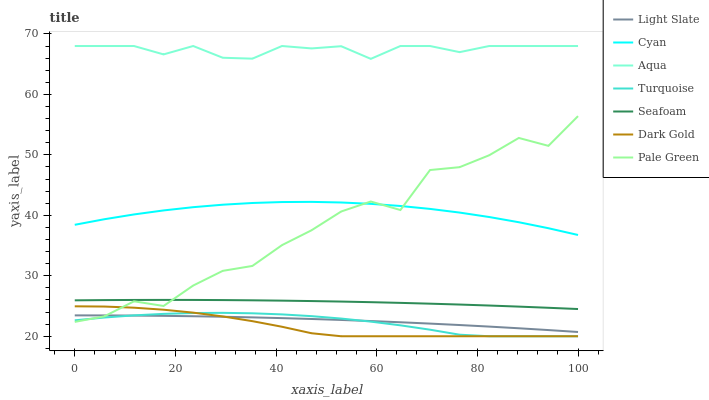Does Dark Gold have the minimum area under the curve?
Answer yes or no. Yes. Does Aqua have the maximum area under the curve?
Answer yes or no. Yes. Does Light Slate have the minimum area under the curve?
Answer yes or no. No. Does Light Slate have the maximum area under the curve?
Answer yes or no. No. Is Seafoam the smoothest?
Answer yes or no. Yes. Is Pale Green the roughest?
Answer yes or no. Yes. Is Dark Gold the smoothest?
Answer yes or no. No. Is Dark Gold the roughest?
Answer yes or no. No. Does Turquoise have the lowest value?
Answer yes or no. Yes. Does Light Slate have the lowest value?
Answer yes or no. No. Does Aqua have the highest value?
Answer yes or no. Yes. Does Dark Gold have the highest value?
Answer yes or no. No. Is Light Slate less than Aqua?
Answer yes or no. Yes. Is Cyan greater than Seafoam?
Answer yes or no. Yes. Does Pale Green intersect Seafoam?
Answer yes or no. Yes. Is Pale Green less than Seafoam?
Answer yes or no. No. Is Pale Green greater than Seafoam?
Answer yes or no. No. Does Light Slate intersect Aqua?
Answer yes or no. No. 